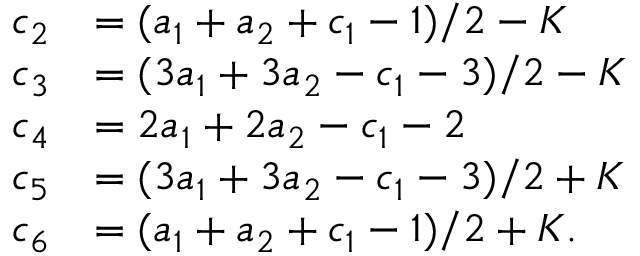Convert formula to latex. <formula><loc_0><loc_0><loc_500><loc_500>{ \begin{array} { r l } { c _ { 2 } } & { = ( a _ { 1 } + a _ { 2 } + c _ { 1 } - 1 ) / 2 - K } \\ { c _ { 3 } } & { = ( 3 a _ { 1 } + 3 a _ { 2 } - c _ { 1 } - 3 ) / 2 - K } \\ { c _ { 4 } } & { = 2 a _ { 1 } + 2 a _ { 2 } - c _ { 1 } - 2 } \\ { c _ { 5 } } & { = ( 3 a _ { 1 } + 3 a _ { 2 } - c _ { 1 } - 3 ) / 2 + K } \\ { c _ { 6 } } & { = ( a _ { 1 } + a _ { 2 } + c _ { 1 } - 1 ) / 2 + K . } \end{array} }</formula> 